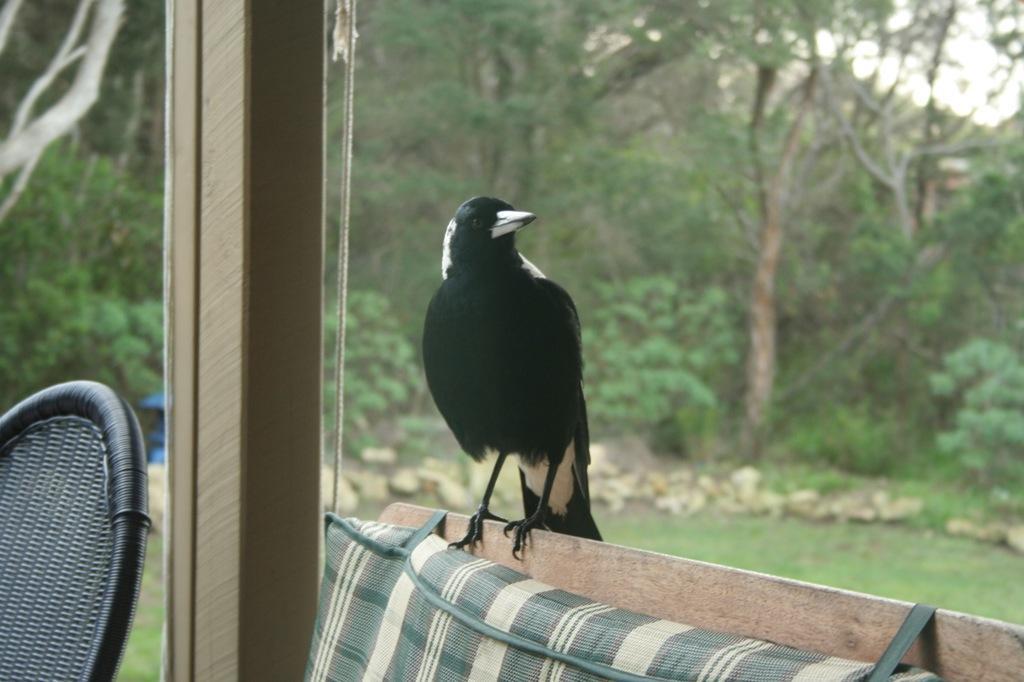Can you describe this image briefly? This picture shows a chair and a crow on the wooden sofa and we see a cushion to it and we see trees and grass on the ground and few stones. Crow is black in color. 